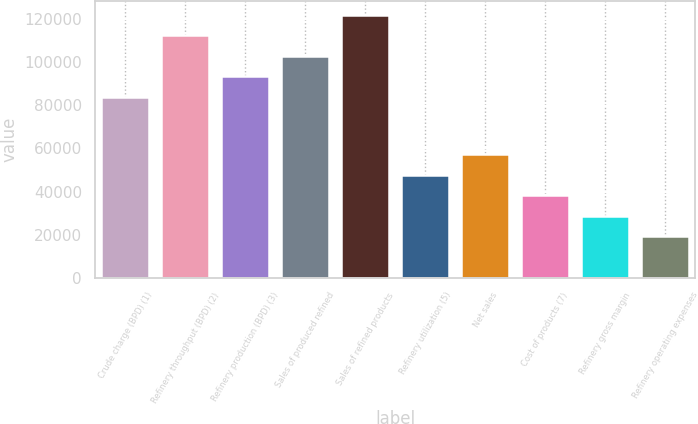<chart> <loc_0><loc_0><loc_500><loc_500><bar_chart><fcel>Crude charge (BPD) (1)<fcel>Refinery throughput (BPD) (2)<fcel>Refinery production (BPD) (3)<fcel>Sales of produced refined<fcel>Sales of refined products<fcel>Refinery utilization (5)<fcel>Net sales<fcel>Cost of products (7)<fcel>Refinery gross margin<fcel>Refinery operating expenses<nl><fcel>83900<fcel>112636<fcel>93478.8<fcel>103058<fcel>122215<fcel>47896.2<fcel>57474.9<fcel>38317.4<fcel>28738.6<fcel>19159.8<nl></chart> 